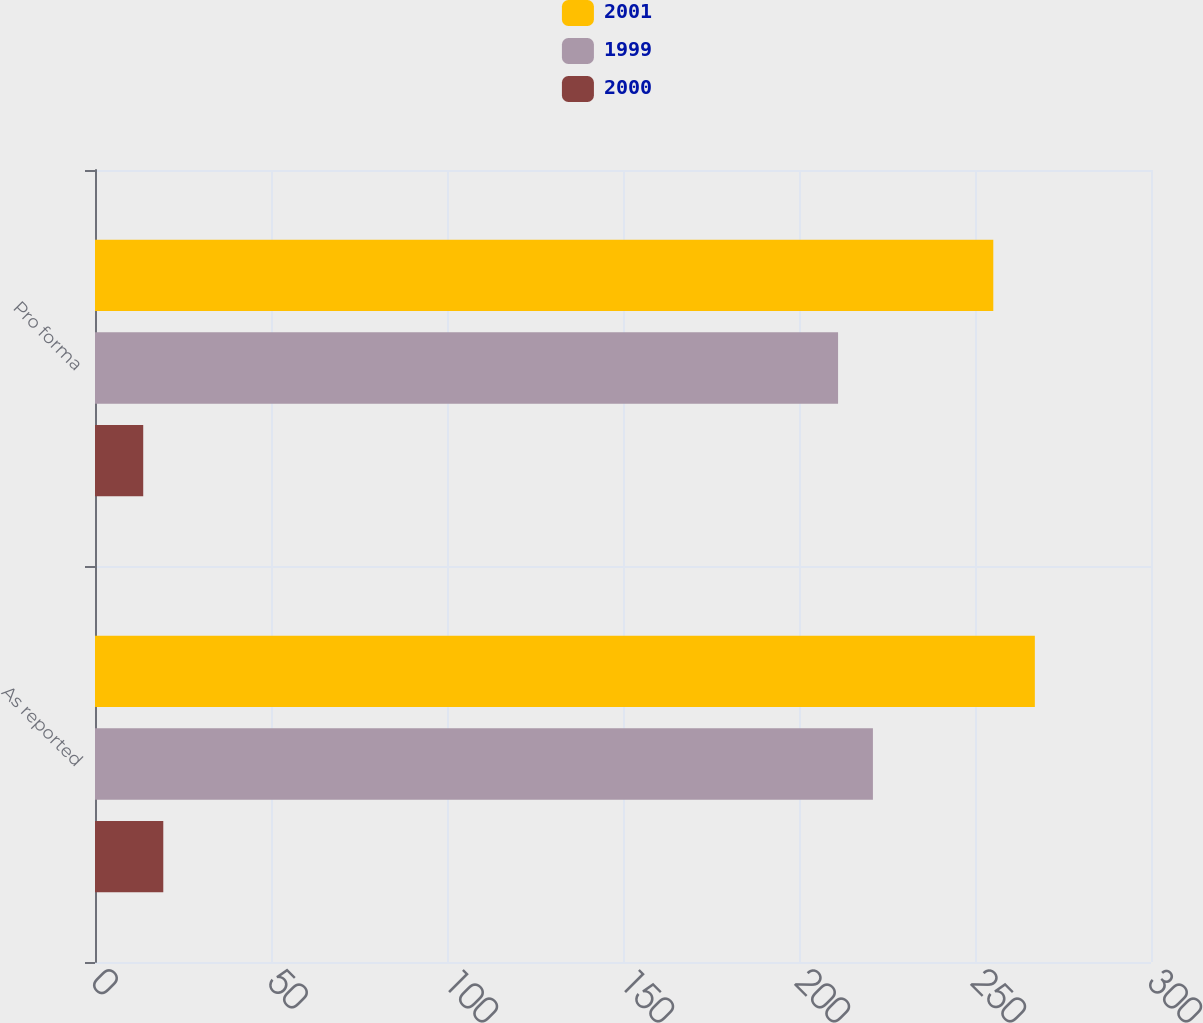Convert chart. <chart><loc_0><loc_0><loc_500><loc_500><stacked_bar_chart><ecel><fcel>As reported<fcel>Pro forma<nl><fcel>2001<fcel>267<fcel>255.2<nl><fcel>1999<fcel>221<fcel>211.1<nl><fcel>2000<fcel>19.4<fcel>13.7<nl></chart> 